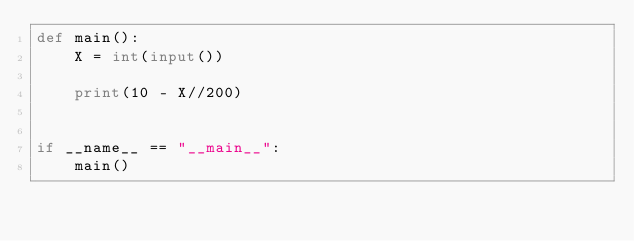<code> <loc_0><loc_0><loc_500><loc_500><_Python_>def main():
    X = int(input())

    print(10 - X//200)


if __name__ == "__main__":
    main()
</code> 